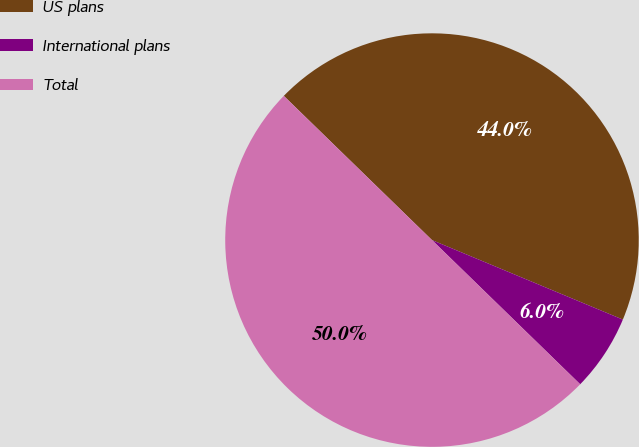Convert chart. <chart><loc_0><loc_0><loc_500><loc_500><pie_chart><fcel>US plans<fcel>International plans<fcel>Total<nl><fcel>44.0%<fcel>6.0%<fcel>50.0%<nl></chart> 